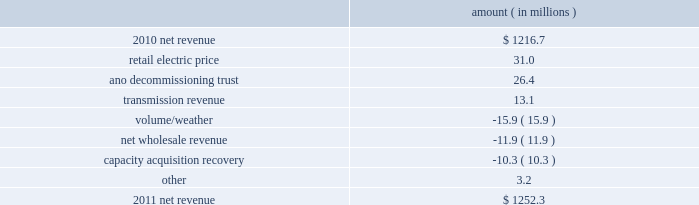Entergy arkansas , inc .
And subsidiaries management 2019s financial discussion and analysis plan to spin off the utility 2019s transmission business see the 201cplan to spin off the utility 2019s transmission business 201d section of entergy corporation and subsidiaries management 2019s financial discussion and analysis for a discussion of this matter , including the planned retirement of debt and preferred securities .
Results of operations net income 2011 compared to 2010 net income decreased $ 7.7 million primarily due to a higher effective income tax rate , lower other income , and higher other operation and maintenance expenses , substantially offset by higher net revenue , lower depreciation and amortization expenses , and lower interest expense .
2010 compared to 2009 net income increased $ 105.7 million primarily due to higher net revenue , a lower effective income tax rate , higher other income , and lower depreciation and amortization expenses , partially offset by higher other operation and maintenance expenses .
Net revenue 2011 compared to 2010 net revenue consists of operating revenues net of : 1 ) fuel , fuel-related expenses , and gas purchased for resale , 2 ) purchased power expenses , and 3 ) other regulatory charges ( credits ) .
Following is an analysis of the change in net revenue comparing 2011 to 2010 .
Amount ( in millions ) .
The retail electric price variance is primarily due to a base rate increase effective july 2010 .
See note 2 to the financial statements for more discussion of the rate case settlement .
The ano decommissioning trust variance is primarily related to the deferral of investment gains from the ano 1 and 2 decommissioning trust in 2010 in accordance with regulatory treatment .
The gains resulted in an increase in 2010 in interest and investment income and a corresponding increase in regulatory charges with no effect on net income. .
What is the percent increase in net revenue from 2010 to 2011? 
Computations: ((1252.3 - 1216.7) / 1216.7)
Answer: 0.02926. Entergy arkansas , inc .
And subsidiaries management 2019s financial discussion and analysis plan to spin off the utility 2019s transmission business see the 201cplan to spin off the utility 2019s transmission business 201d section of entergy corporation and subsidiaries management 2019s financial discussion and analysis for a discussion of this matter , including the planned retirement of debt and preferred securities .
Results of operations net income 2011 compared to 2010 net income decreased $ 7.7 million primarily due to a higher effective income tax rate , lower other income , and higher other operation and maintenance expenses , substantially offset by higher net revenue , lower depreciation and amortization expenses , and lower interest expense .
2010 compared to 2009 net income increased $ 105.7 million primarily due to higher net revenue , a lower effective income tax rate , higher other income , and lower depreciation and amortization expenses , partially offset by higher other operation and maintenance expenses .
Net revenue 2011 compared to 2010 net revenue consists of operating revenues net of : 1 ) fuel , fuel-related expenses , and gas purchased for resale , 2 ) purchased power expenses , and 3 ) other regulatory charges ( credits ) .
Following is an analysis of the change in net revenue comparing 2011 to 2010 .
Amount ( in millions ) .
The retail electric price variance is primarily due to a base rate increase effective july 2010 .
See note 2 to the financial statements for more discussion of the rate case settlement .
The ano decommissioning trust variance is primarily related to the deferral of investment gains from the ano 1 and 2 decommissioning trust in 2010 in accordance with regulatory treatment .
The gains resulted in an increase in 2010 in interest and investment income and a corresponding increase in regulatory charges with no effect on net income. .
What was the percent of the change in the net revenue in 2011? 
Computations: (1252.3 - 1216.7)
Answer: 35.6. 